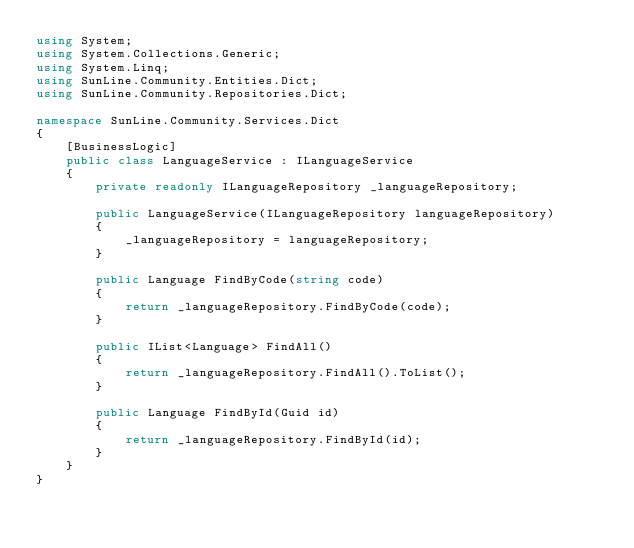Convert code to text. <code><loc_0><loc_0><loc_500><loc_500><_C#_>using System;
using System.Collections.Generic;
using System.Linq;
using SunLine.Community.Entities.Dict;
using SunLine.Community.Repositories.Dict;

namespace SunLine.Community.Services.Dict
{
    [BusinessLogic]
    public class LanguageService : ILanguageService
    {
        private readonly ILanguageRepository _languageRepository;

        public LanguageService(ILanguageRepository languageRepository)
        {
            _languageRepository = languageRepository;
        }

        public Language FindByCode(string code)
        {
            return _languageRepository.FindByCode(code);
        }

        public IList<Language> FindAll()
        {
            return _languageRepository.FindAll().ToList();
        }

        public Language FindById(Guid id)
        {
            return _languageRepository.FindById(id);
        }
    }
}
</code> 